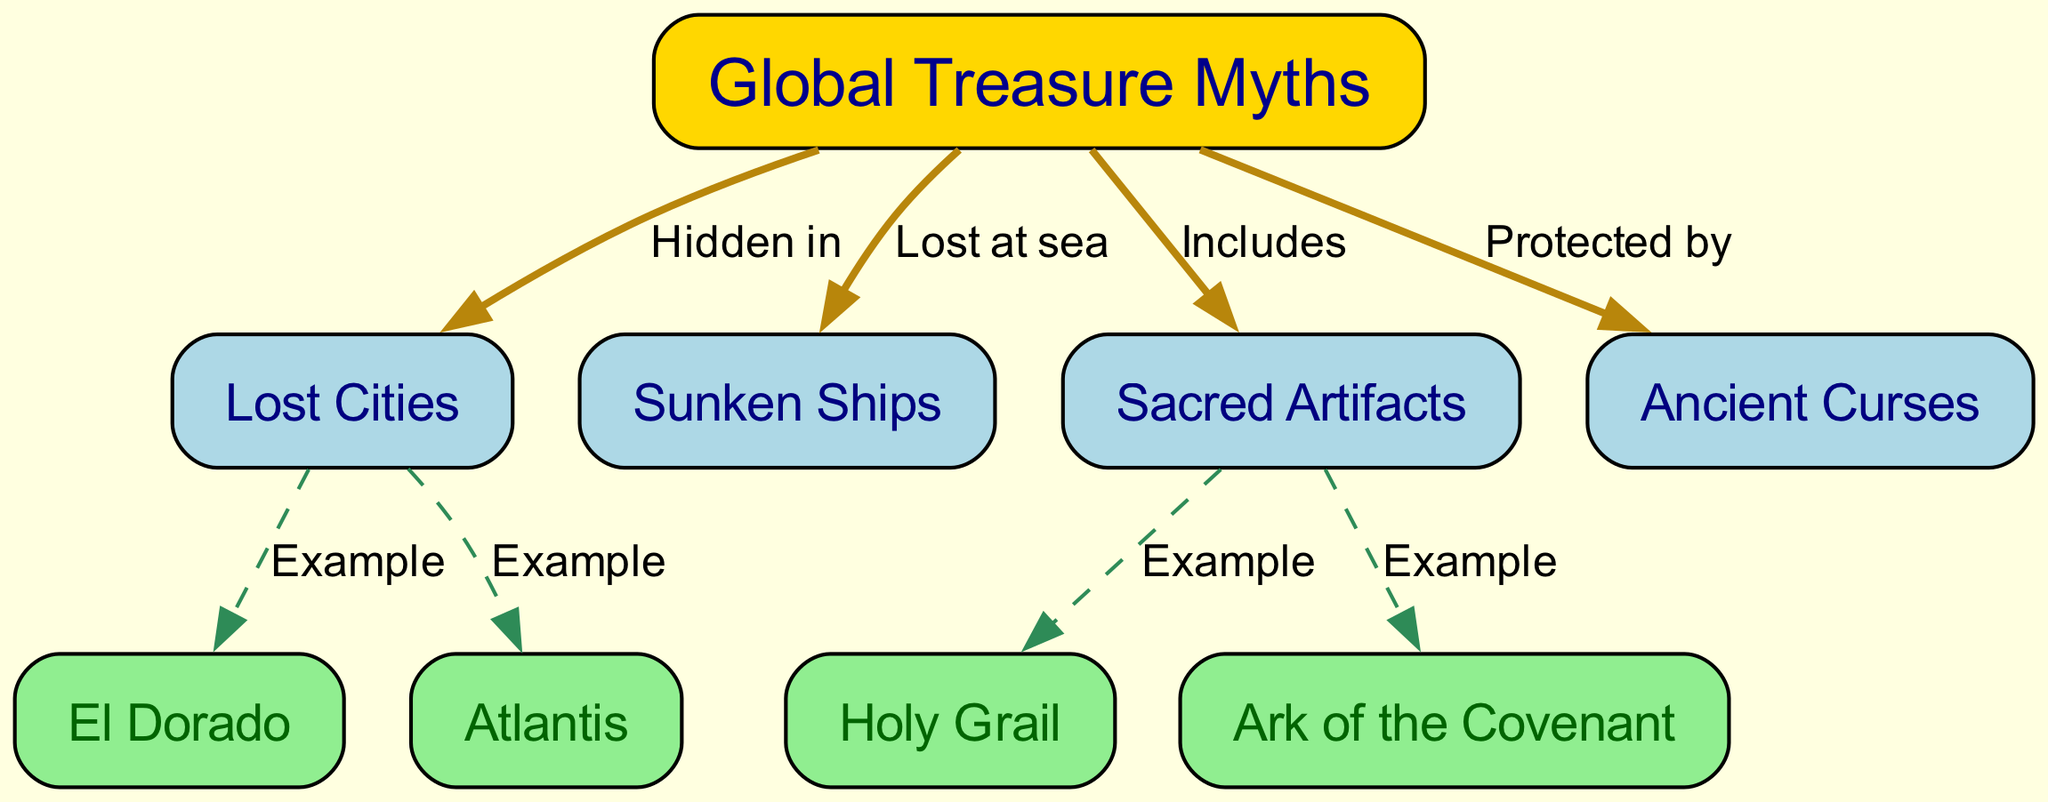What is the main topic of the concept map? The main topic, which is represented at the top of the diagram, is "Global Treasure Myths". It encapsulates all the related themes and examples that branch from this central idea.
Answer: Global Treasure Myths How many nodes are there in the diagram? Counting all the unique labeled nodes present in the diagram, there are a total of 9 nodes.
Answer: 9 Which node is an example of a lost city? The node specifically labeled as "El Dorado" is an example provided under the "Lost Cities" category in the diagram, highlighting its thematic connection to treasure myths.
Answer: El Dorado What is included in global treasure myths? The diagram mentions "Sacred Artifacts" as one of the categories that are included within the larger theme of global treasure myths, indicating it is a significant subset.
Answer: Sacred Artifacts How many edges connect to "Sacred Artifacts"? By visually inspecting the connections, it can be noted that there are 2 edges leading out from "Sacred Artifacts" to different nodes: "Holy Grail" and "Ark of the Covenant".
Answer: 2 What protects global treasure myths? According to the diagram, "Ancient Curses" are depicted as the protective elements around "Global Treasure Myths", suggesting a common theme within these legends.
Answer: Ancient Curses Which two myths are categorized under lost cities? Within the "Lost Cities" node, both "El Dorado" and "Atlantis" are explicitly classified as examples, representing notable myths in this category of treasure tales.
Answer: El Dorado and Atlantis What is an example of a sacred artifact? The diagram provides "Holy Grail" as an example of a "Sacred Artifact", illustrating how specific treasures are categorized under this theme.
Answer: Holy Grail What type of treasures are lost at sea? The concept map indicates that "Sunken Ships" are the category of treasures that are specifically described as being lost at sea, linking maritime lore to treasure myths.
Answer: Sunken Ships 